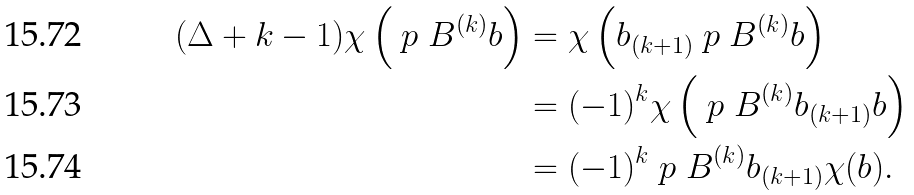Convert formula to latex. <formula><loc_0><loc_0><loc_500><loc_500>( \Delta + k - 1 ) \chi \left ( \ p _ { \ } B ^ { ( k ) } b \right ) & = \chi \left ( b _ { ( k + 1 ) } \ p _ { \ } B ^ { ( k ) } b \right ) \\ & = ( - 1 ) ^ { k } \chi \left ( \ p _ { \ } B ^ { ( k ) } b _ { ( k + 1 ) } b \right ) \\ & = ( - 1 ) ^ { k } \ p _ { \ } B ^ { ( k ) } b _ { ( k + 1 ) } \chi ( b ) .</formula> 